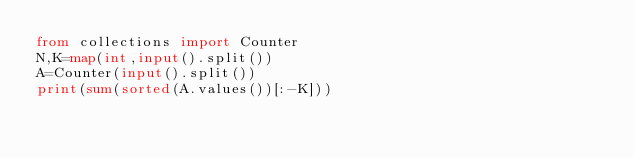<code> <loc_0><loc_0><loc_500><loc_500><_Python_>from collections import Counter
N,K=map(int,input().split())
A=Counter(input().split())
print(sum(sorted(A.values())[:-K]))
</code> 